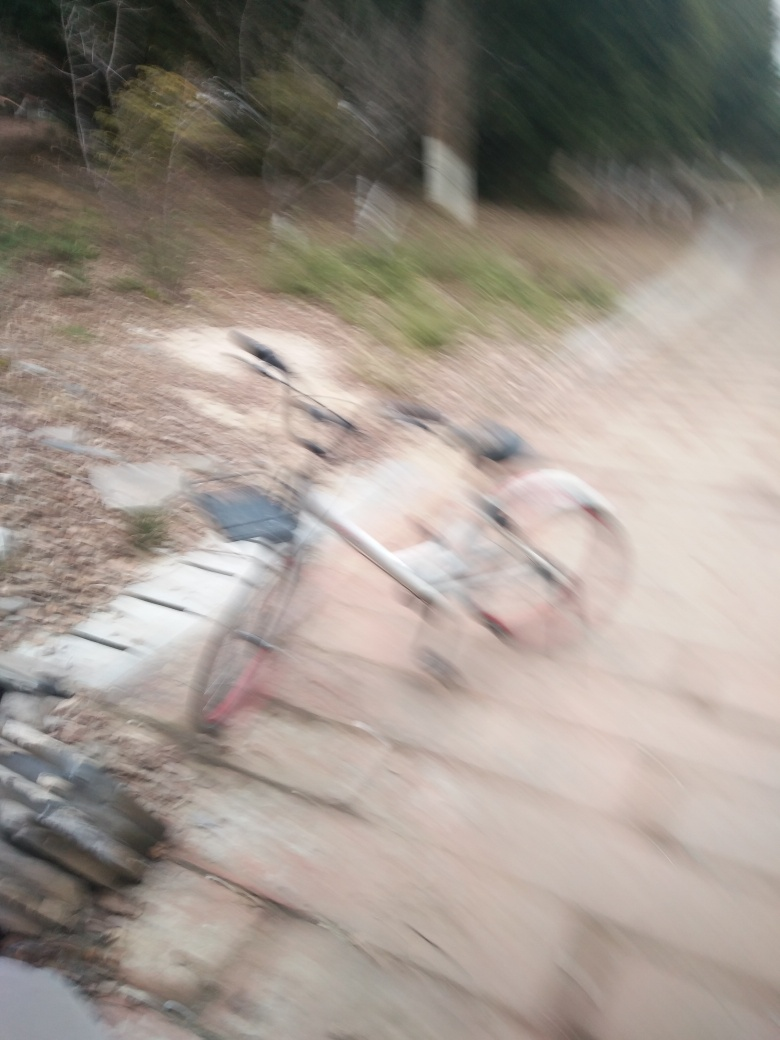What possible reasons could there be for the blurriness of this photo? There are several potential causes for the blurriness in this photo. It could be due to a slow shutter speed combined with camera shake or movement, which results in motion blur. Alternatively, it might indicate that the camera's focus was incorrectly set when the photo was captured. Environmental factors, such as rain, fog, or even a dirty camera lens, could also contribute to the lack of sharpness in the image. 